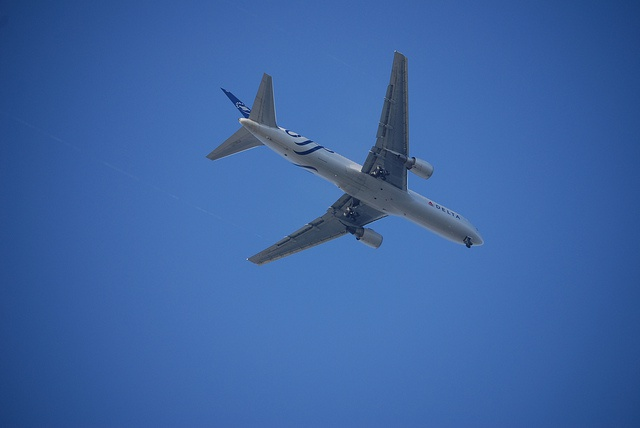Describe the objects in this image and their specific colors. I can see a airplane in darkblue, gray, and navy tones in this image. 